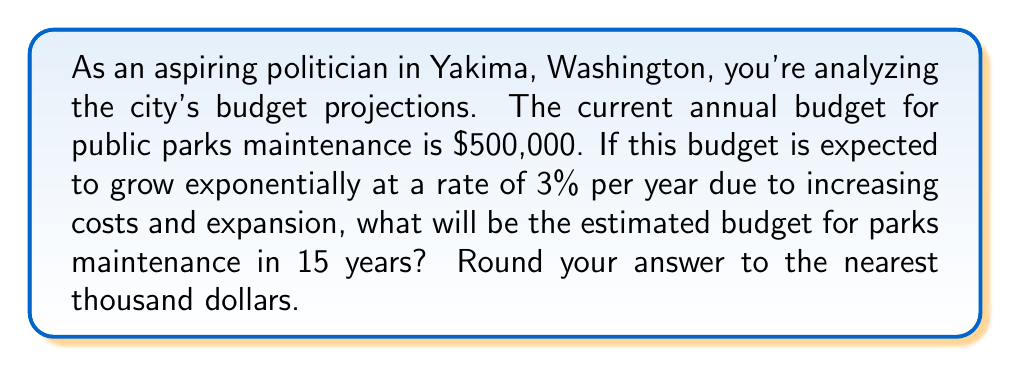Give your solution to this math problem. To solve this problem, we'll use the exponential growth formula:

$$A = P(1 + r)^t$$

Where:
$A$ = Final amount
$P$ = Initial principal balance
$r$ = Annual growth rate (as a decimal)
$t$ = Number of years

Given:
$P = \$500,000$ (initial budget)
$r = 0.03$ (3% written as a decimal)
$t = 15$ years

Let's substitute these values into the formula:

$$A = 500,000(1 + 0.03)^{15}$$

Now, let's calculate step-by-step:

1) First, calculate $(1 + 0.03)^{15}$:
   $$(1.03)^{15} \approx 1.5580$$

2) Multiply this by the initial amount:
   $$500,000 \times 1.5580 \approx 778,983.61$$

3) Rounding to the nearest thousand:
   $$778,983.61 \approx 779,000$$

Therefore, the estimated budget for parks maintenance in 15 years will be approximately $779,000.
Answer: $779,000 